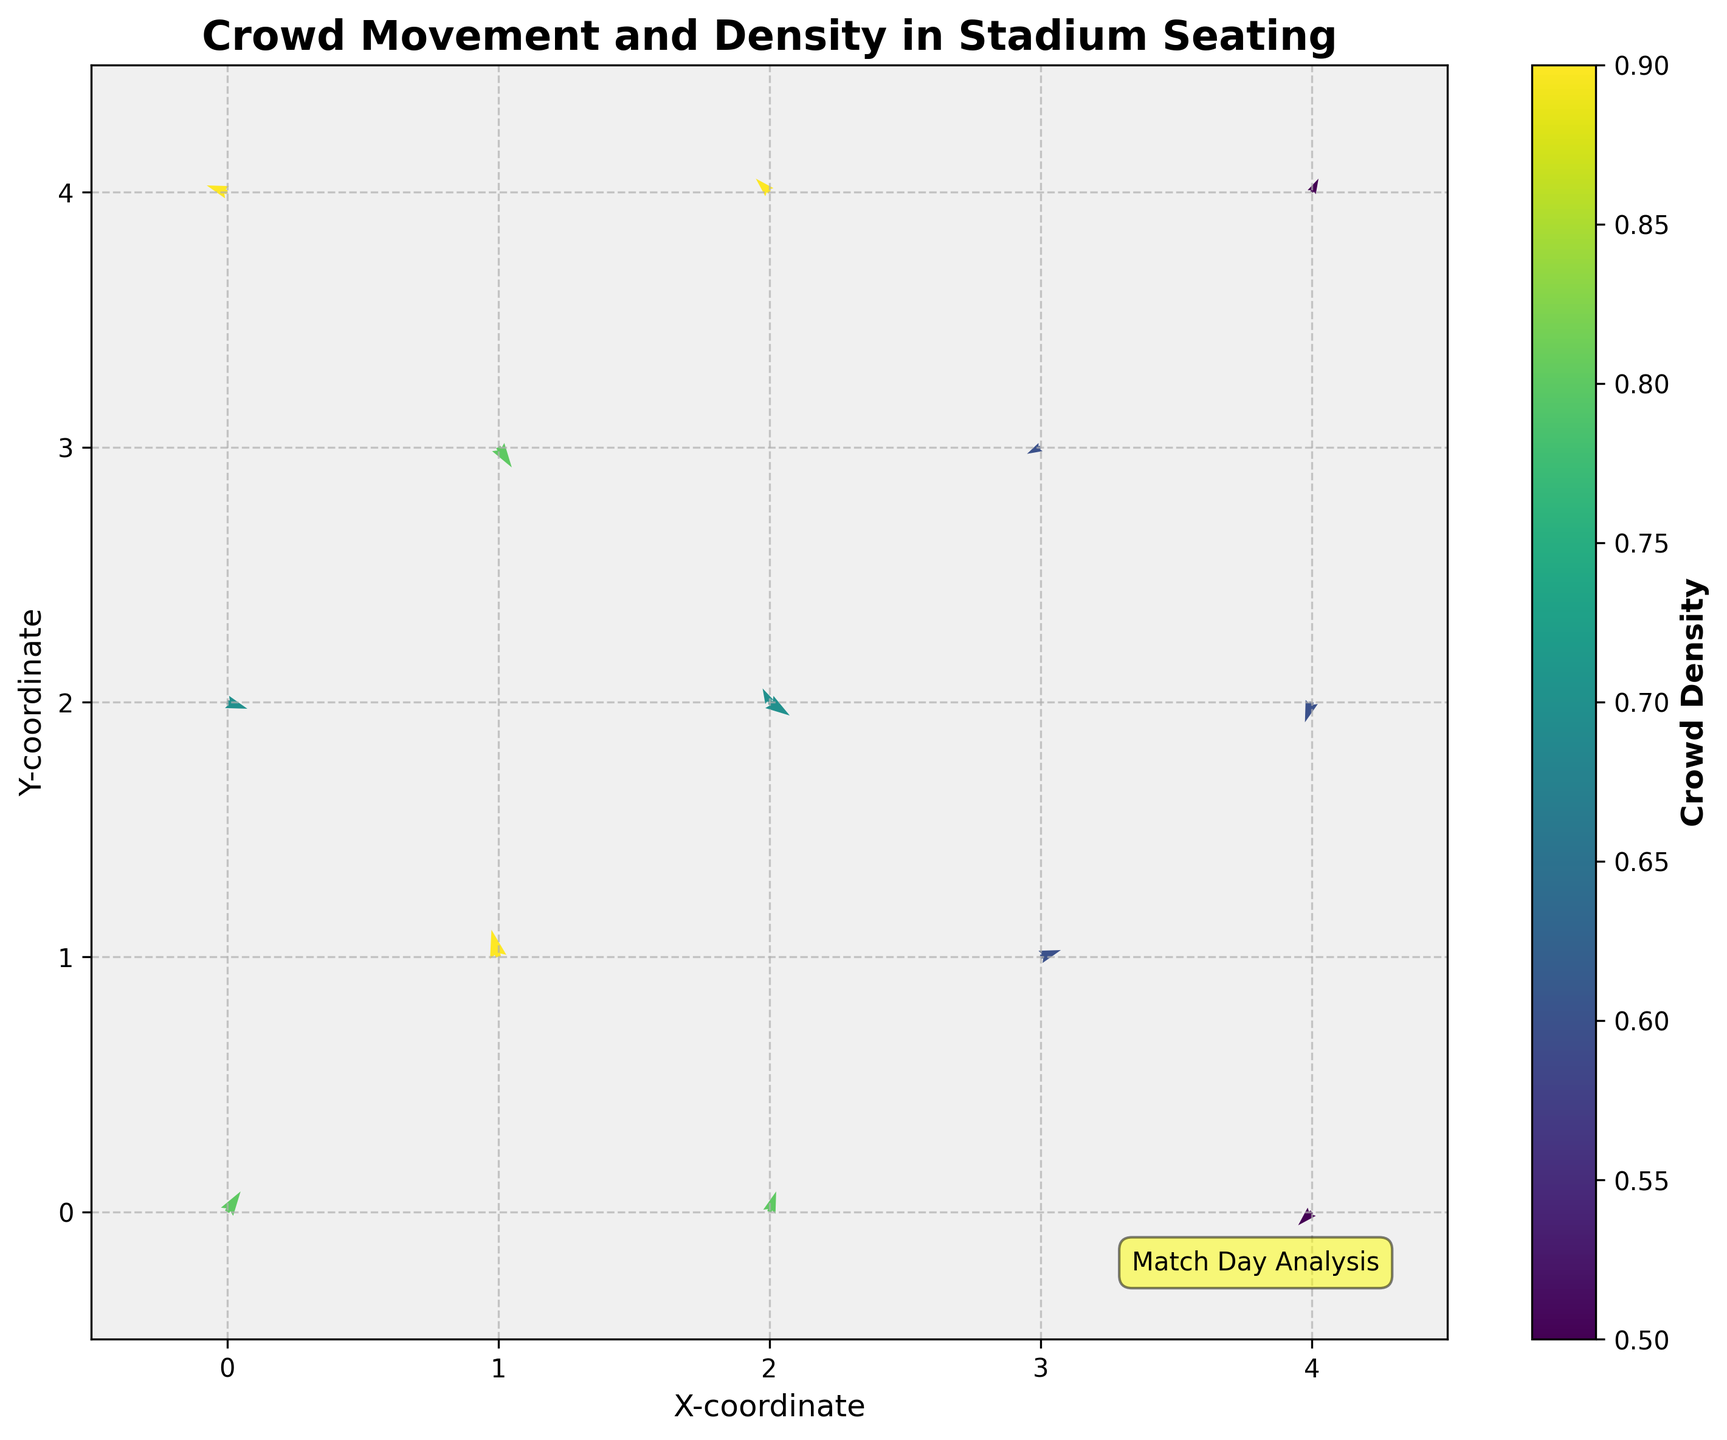What is the title of the figure? The title is located at the top of the figure and reads "Crowd Movement and Density in Stadium Seating".
Answer: Crowd Movement and Density in Stadium Seating What do the arrows represent in the figure? The arrows in a quiver plot indicate the direction and magnitude of movement. In this figure, they show the direction and movement of the crowd at various points in the stadium.
Answer: Crowd direction and movement What does the color of the arrows signify? The color of the arrows corresponds to the crowd density at each point, as indicated by the color bar on the right side of the plot. Darker colors reflect higher density, and lighter colors reflect lower density.
Answer: Crowd density Which coordinate point has the highest crowd density? The point with the highest crowd density can be identified by the darkest color of the arrow. The color bar indicates the range of densities, and the darkest color corresponds to a density of 0.9. The point (1,1) has an arrow with this color.
Answer: (1,1) Are there any points where the crowd is moving upwards? Crowd movement upwards corresponds to positive values in the y-component of the vectors (v). Points with arrows pointing up include (0,0), (1,1), and (2,0).
Answer: Yes How many points have a crowd density of 0.9? Checking the data and the color scheme, arrows with the darkest shade, corresponding to 0.9 on the color bar, appear at the points (1,1), (0,4), and (2,4).
Answer: 3 points Which direction is the crowd moving at (2,2)? The arrow at (2,2) points in the direction given by the vector components (u,v), which are (0.3, -0.2). This indicates the crowd is moving downwards and slightly to the right.
Answer: Downwards right On average, is the crowd density higher in the top half or the bottom half of the plot? To find this, divide the plot into top half (y > 2) and bottom half (y ≤ 2). Then, calculate the average density for each half. The average density for the top half (points where y = 3 or 4) is: (0.9 + 0.8 + 0.6 + 0.5 + 0.9)/5 = 0.74. The average density for the bottom half (points where y = 0, 1, or 2) is: (0.8 + 0.5 + 0.5 + 0.6 + 0.7 + 0.8 + 0.7 + 0.6 + 0.8)/9 = 0.66. Therefore, the average density is higher in the top half.
Answer: Top half Which coordinate has a crowd moving most directly to the left? Movements to the left have a negative x-component (u). The most negative value in u is -0.3, which occurs at the coordinates (0,4) and (2,4).
Answer: (0,4) and (2,4) Is there any coordinate point where the crowd is stationary? A stationary crowd would be indicated by an arrow with zero magnitude, where both u and v are 0. Since none of the given vectors have both u = 0 and v = 0, there is no point where the crowd is stationary.
Answer: No 